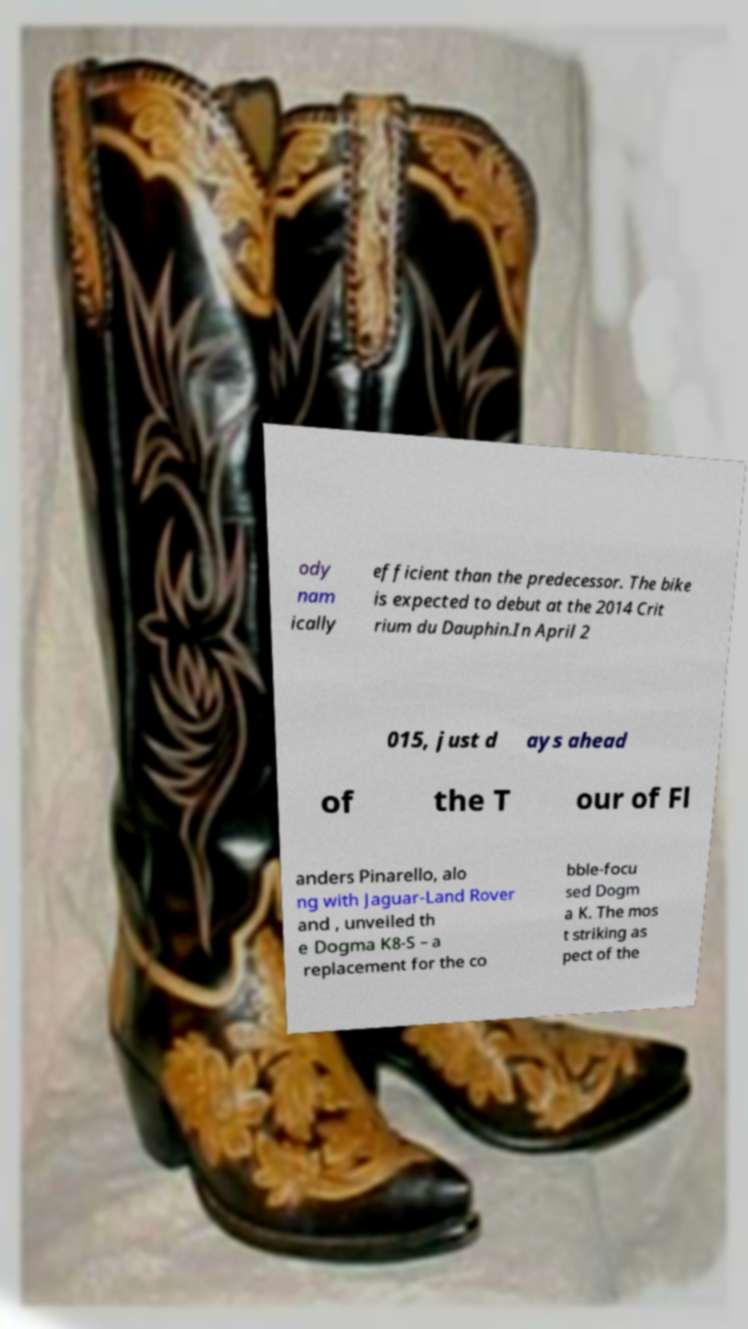Can you read and provide the text displayed in the image?This photo seems to have some interesting text. Can you extract and type it out for me? ody nam ically efficient than the predecessor. The bike is expected to debut at the 2014 Crit rium du Dauphin.In April 2 015, just d ays ahead of the T our of Fl anders Pinarello, alo ng with Jaguar-Land Rover and , unveiled th e Dogma K8-S – a replacement for the co bble-focu sed Dogm a K. The mos t striking as pect of the 